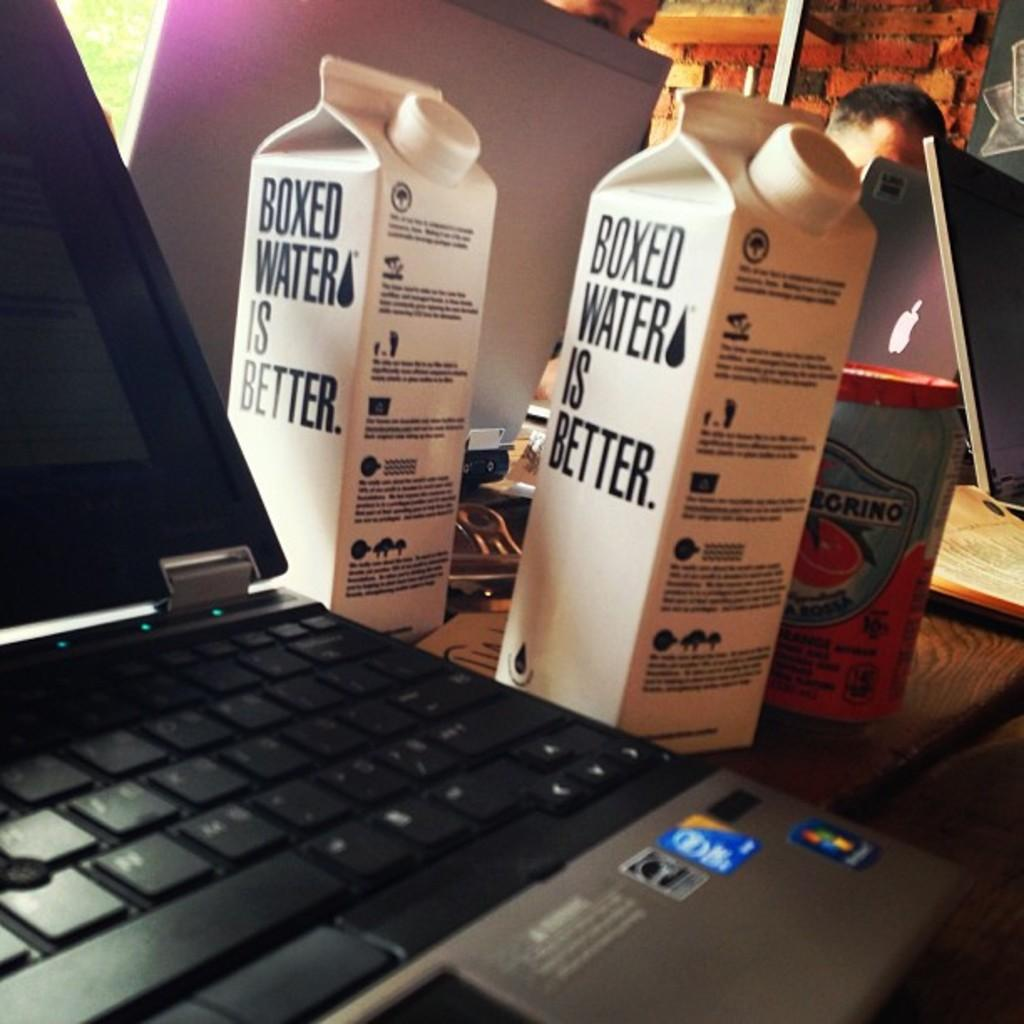<image>
Give a short and clear explanation of the subsequent image. Next to a laptop computer are two white containers of Boxed water. 